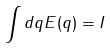<formula> <loc_0><loc_0><loc_500><loc_500>\int d q E ( q ) = I</formula> 